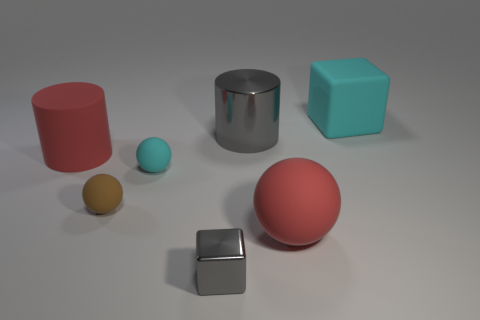Can you describe the size relationships between the objects in the image? Certainly! The image displays a range of sizes, from the small yellow sphere to the larger red cylinder and pink sphere. The gray cube and the larger gray object of a cylindrical shape suggest a progression in size that provides a sense of depth and perspective in the composition. 